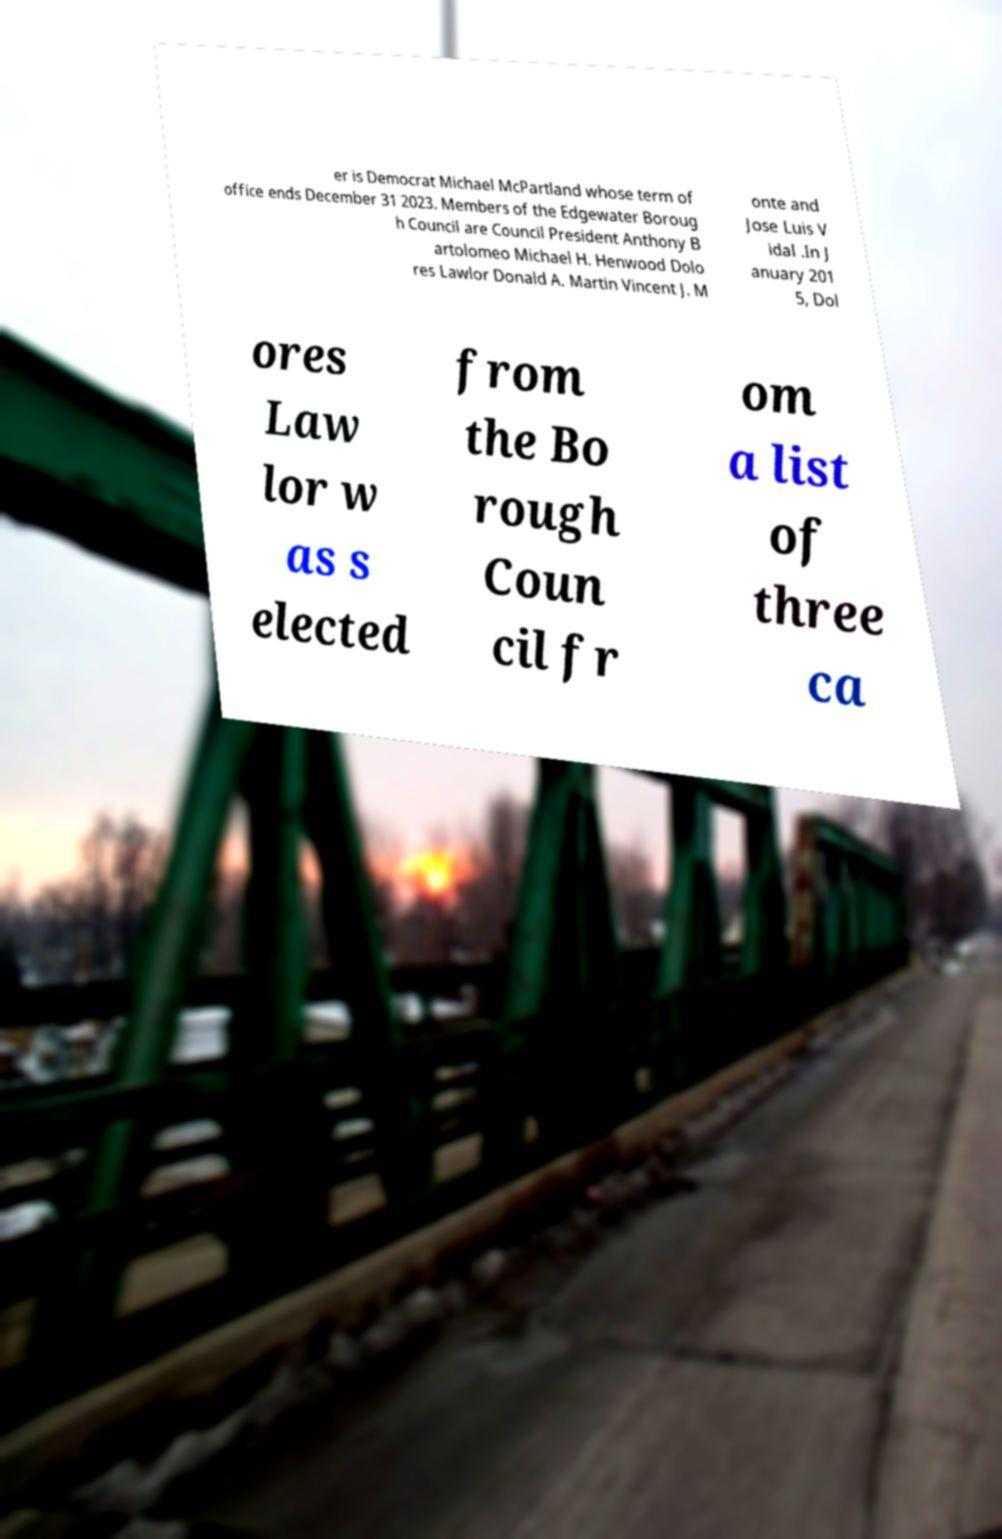What messages or text are displayed in this image? I need them in a readable, typed format. er is Democrat Michael McPartland whose term of office ends December 31 2023. Members of the Edgewater Boroug h Council are Council President Anthony B artolomeo Michael H. Henwood Dolo res Lawlor Donald A. Martin Vincent J. M onte and Jose Luis V idal .In J anuary 201 5, Dol ores Law lor w as s elected from the Bo rough Coun cil fr om a list of three ca 